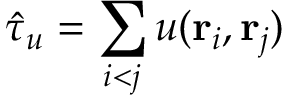Convert formula to latex. <formula><loc_0><loc_0><loc_500><loc_500>\hat { \tau } _ { u } = \sum _ { i < j } u ( { r _ { i } } , { r _ { j } } )</formula> 